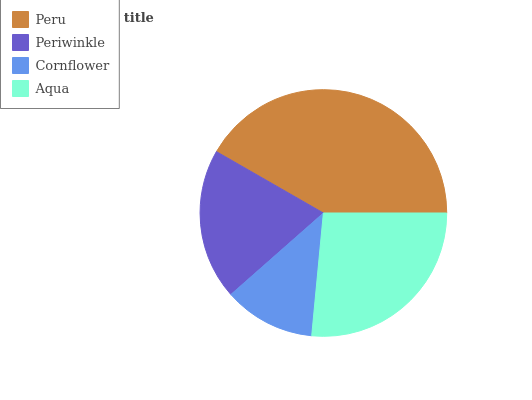Is Cornflower the minimum?
Answer yes or no. Yes. Is Peru the maximum?
Answer yes or no. Yes. Is Periwinkle the minimum?
Answer yes or no. No. Is Periwinkle the maximum?
Answer yes or no. No. Is Peru greater than Periwinkle?
Answer yes or no. Yes. Is Periwinkle less than Peru?
Answer yes or no. Yes. Is Periwinkle greater than Peru?
Answer yes or no. No. Is Peru less than Periwinkle?
Answer yes or no. No. Is Aqua the high median?
Answer yes or no. Yes. Is Periwinkle the low median?
Answer yes or no. Yes. Is Periwinkle the high median?
Answer yes or no. No. Is Peru the low median?
Answer yes or no. No. 